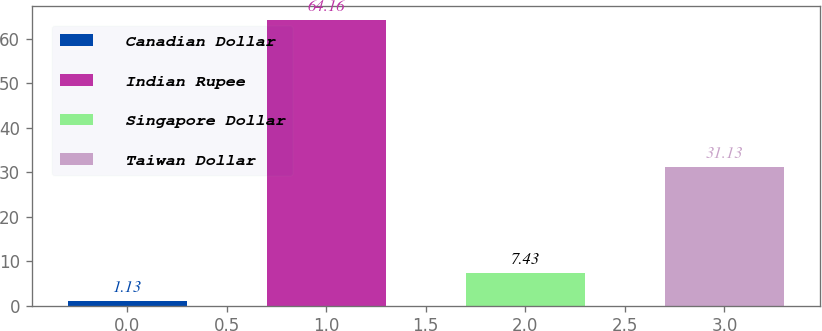Convert chart to OTSL. <chart><loc_0><loc_0><loc_500><loc_500><bar_chart><fcel>Canadian Dollar<fcel>Indian Rupee<fcel>Singapore Dollar<fcel>Taiwan Dollar<nl><fcel>1.13<fcel>64.16<fcel>7.43<fcel>31.13<nl></chart> 